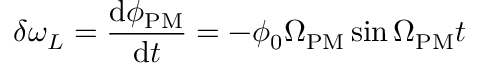<formula> <loc_0><loc_0><loc_500><loc_500>\delta \omega _ { L } = \frac { d \phi _ { P M } } { d t } = - \phi _ { 0 } \Omega _ { P M } \sin \Omega _ { P M } t</formula> 